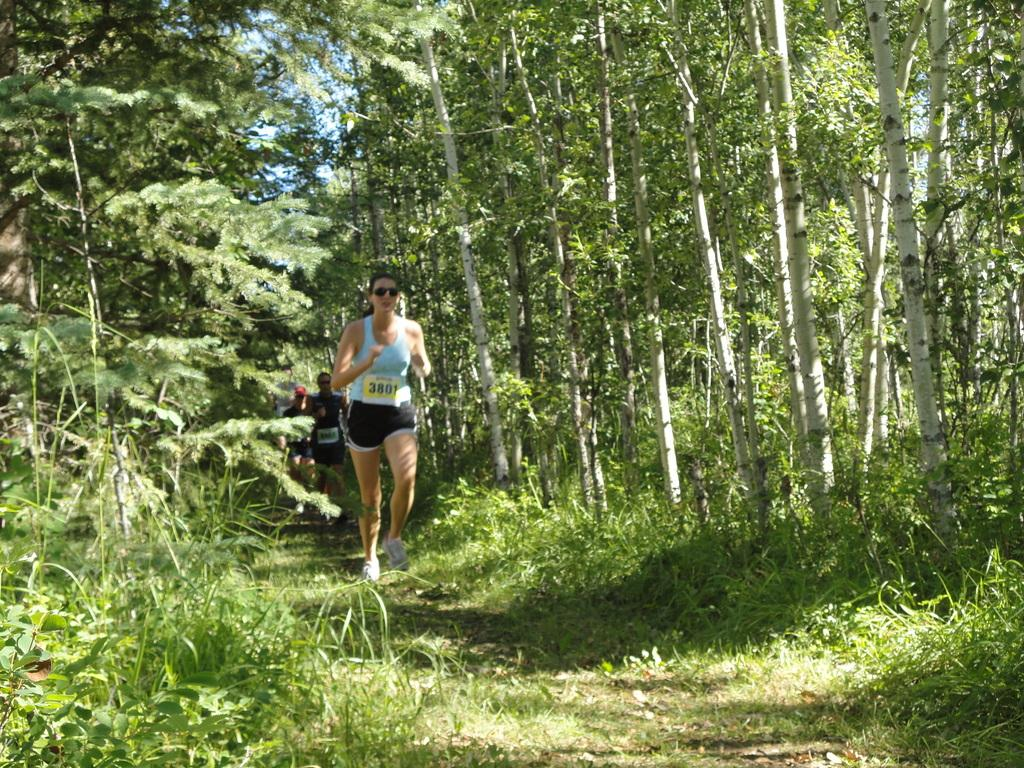What is happening in the image involving the group of people? The people in the image are running. What type of environment is depicted in the image? There are trees and grass in the image, suggesting a natural setting. What is visible at the top of the image? The sky is visible at the top of the image. What type of passenger is being transported by the system in the image? There is no system or passenger present in the image; it features a group of people running in a natural setting. 